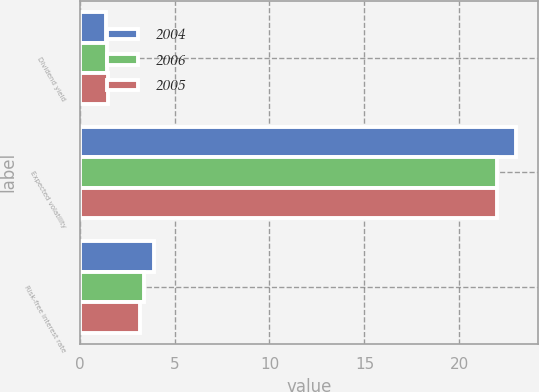Convert chart. <chart><loc_0><loc_0><loc_500><loc_500><stacked_bar_chart><ecel><fcel>Dividend yield<fcel>Expected volatility<fcel>Risk-free interest rate<nl><fcel>2004<fcel>1.4<fcel>23<fcel>3.9<nl><fcel>2006<fcel>1.45<fcel>22<fcel>3.4<nl><fcel>2005<fcel>1.49<fcel>22<fcel>3.2<nl></chart> 